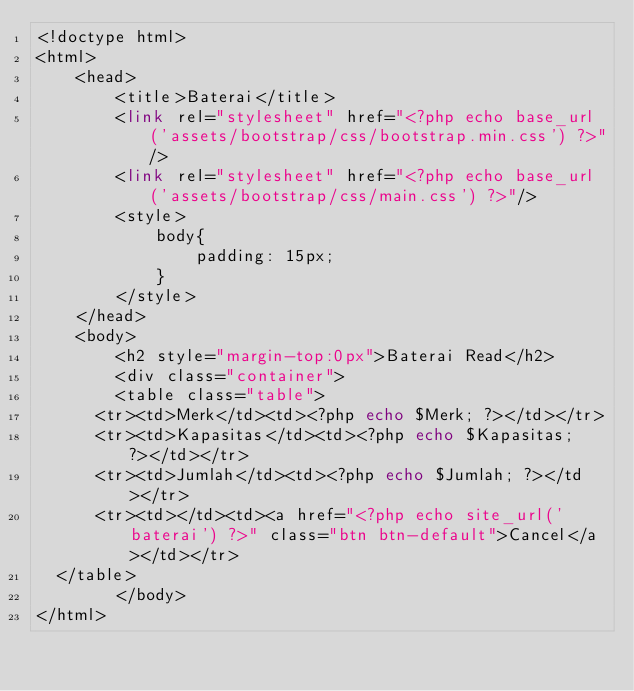Convert code to text. <code><loc_0><loc_0><loc_500><loc_500><_PHP_><!doctype html>
<html>
    <head>
        <title>Baterai</title>
        <link rel="stylesheet" href="<?php echo base_url('assets/bootstrap/css/bootstrap.min.css') ?>"/>
        <link rel="stylesheet" href="<?php echo base_url('assets/bootstrap/css/main.css') ?>"/> 
        <style>
            body{
                padding: 15px;
            }
        </style>
    </head>
    <body>
        <h2 style="margin-top:0px">Baterai Read</h2>
        <div class="container">
        <table class="table">
	    <tr><td>Merk</td><td><?php echo $Merk; ?></td></tr>
	    <tr><td>Kapasitas</td><td><?php echo $Kapasitas; ?></td></tr>
	    <tr><td>Jumlah</td><td><?php echo $Jumlah; ?></td></tr>
	    <tr><td></td><td><a href="<?php echo site_url('baterai') ?>" class="btn btn-default">Cancel</a></td></tr>
	</table>
        </body>
</html></code> 